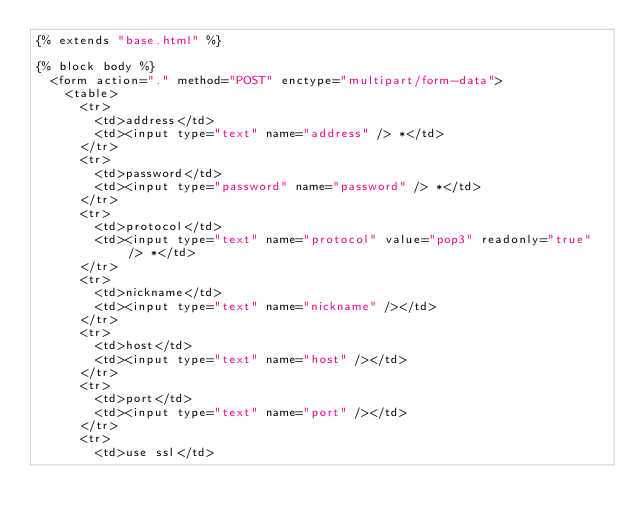<code> <loc_0><loc_0><loc_500><loc_500><_HTML_>{% extends "base.html" %}

{% block body %}
  <form action="." method="POST" enctype="multipart/form-data">
    <table>
      <tr>
        <td>address</td>
        <td><input type="text" name="address" /> *</td>
      </tr>
      <tr>
        <td>password</td>
        <td><input type="password" name="password" /> *</td>
      </tr>
      <tr>
        <td>protocol</td>
        <td><input type="text" name="protocol" value="pop3" readonly="true" /> *</td>
      </tr>
      <tr>
        <td>nickname</td>
        <td><input type="text" name="nickname" /></td>
      </tr>
      <tr>
        <td>host</td>
        <td><input type="text" name="host" /></td>
      </tr>
      <tr>
        <td>port</td>
        <td><input type="text" name="port" /></td>
      </tr>
      <tr>
        <td>use ssl</td></code> 